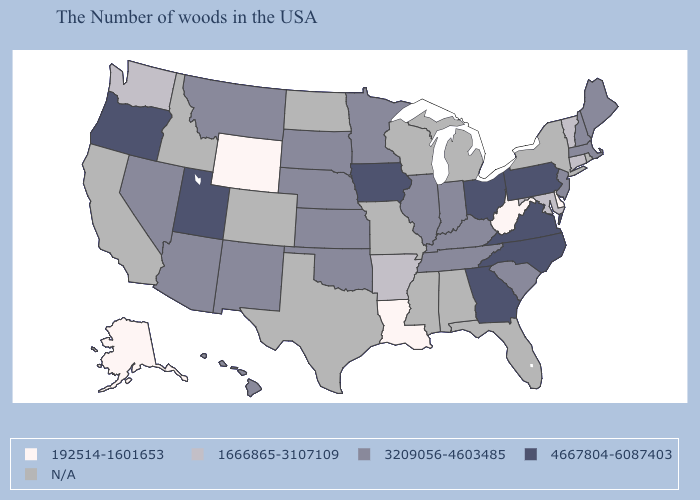Does Kentucky have the lowest value in the USA?
Quick response, please. No. What is the lowest value in the Northeast?
Concise answer only. 1666865-3107109. What is the value of New Hampshire?
Give a very brief answer. 3209056-4603485. Which states have the highest value in the USA?
Answer briefly. Pennsylvania, Virginia, North Carolina, Ohio, Georgia, Iowa, Utah, Oregon. What is the highest value in the USA?
Short answer required. 4667804-6087403. What is the value of Montana?
Answer briefly. 3209056-4603485. Among the states that border Colorado , does New Mexico have the lowest value?
Be succinct. No. Does Alaska have the lowest value in the USA?
Write a very short answer. Yes. Among the states that border South Carolina , which have the highest value?
Write a very short answer. North Carolina, Georgia. What is the value of New Mexico?
Answer briefly. 3209056-4603485. Among the states that border Pennsylvania , which have the lowest value?
Keep it brief. Delaware, West Virginia. What is the value of Florida?
Be succinct. N/A. Name the states that have a value in the range 192514-1601653?
Answer briefly. Delaware, West Virginia, Louisiana, Wyoming, Alaska. What is the value of New Hampshire?
Keep it brief. 3209056-4603485. Does the map have missing data?
Write a very short answer. Yes. 